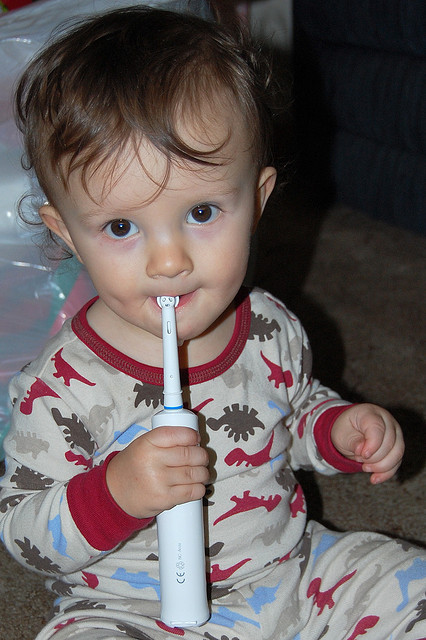<image>Is the child a boy or girl? I am not sure if the child is a boy or girl. The child can be a boy or girl for sure. Is the child a boy or girl? I am not sure if the child is a boy or a girl. It can be seen as both a boy or a girl. 